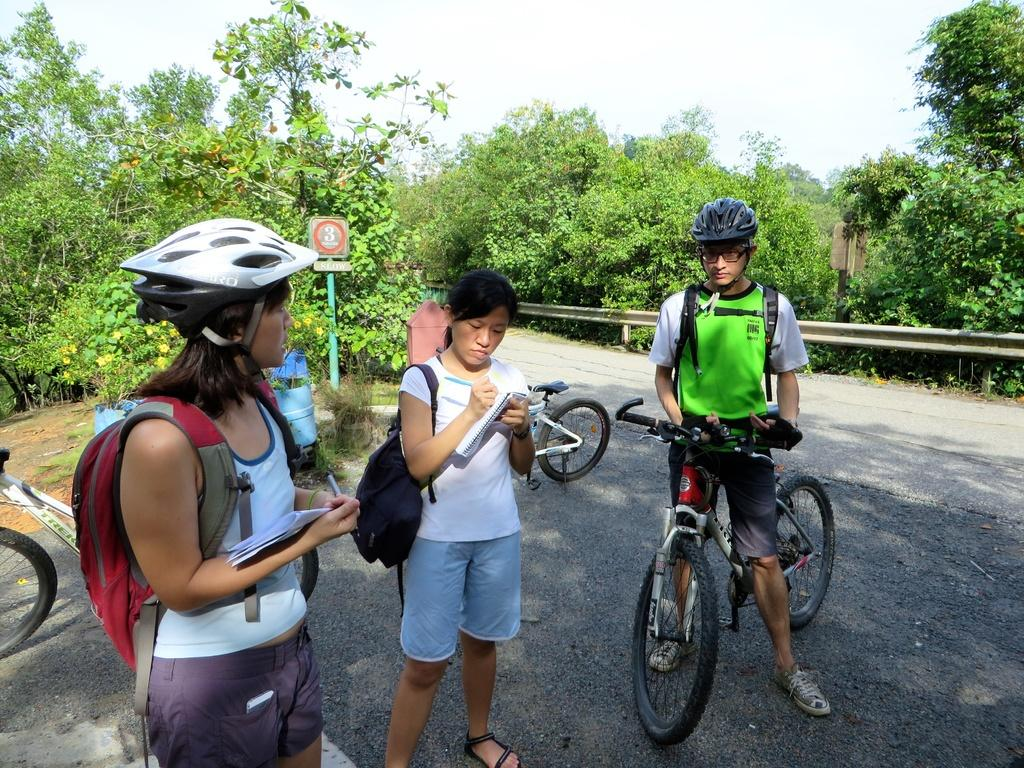What are the people in the image doing? There are people standing in the image. What are some of the people carrying? Some of the people are carrying backpacks. Can you describe the person holding a bicycle? There is a person standing and holding a bicycle. What can be seen in the background of the image? There are trees visible in the background of the image. Where is the advertisement for the zipper located in the image? There is no advertisement or zipper present in the image. What type of basket is being used by the people in the image? There is no basket visible in the image. 